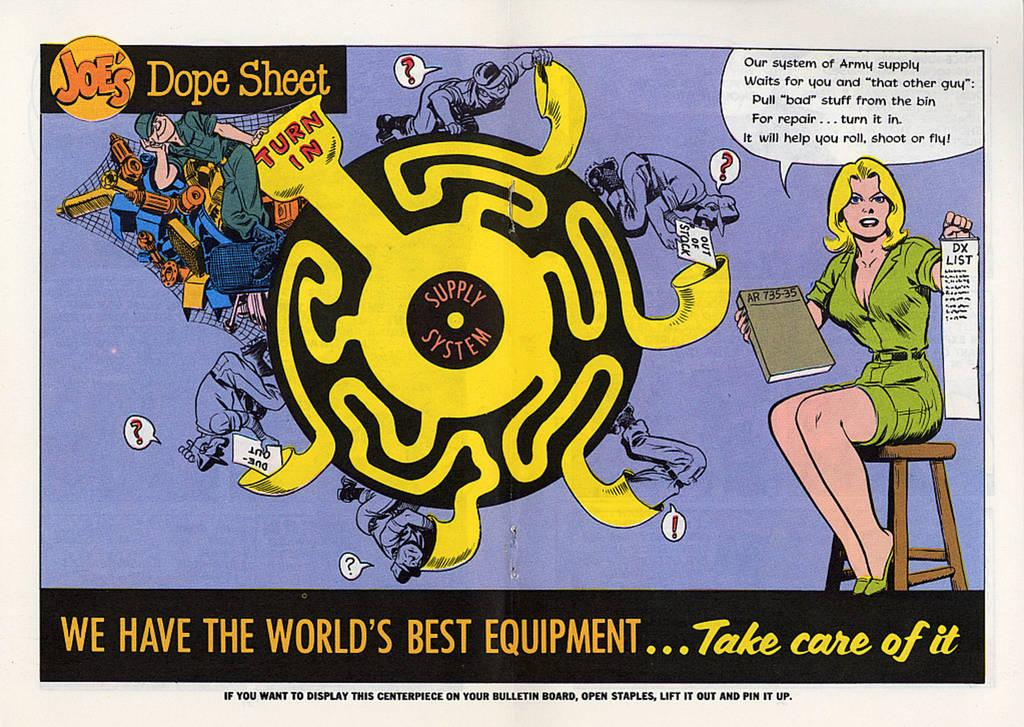Provide a one-sentence caption for the provided image. An old fashioned comic book illustration featuring a maze called Joe's Dope Sheet. 